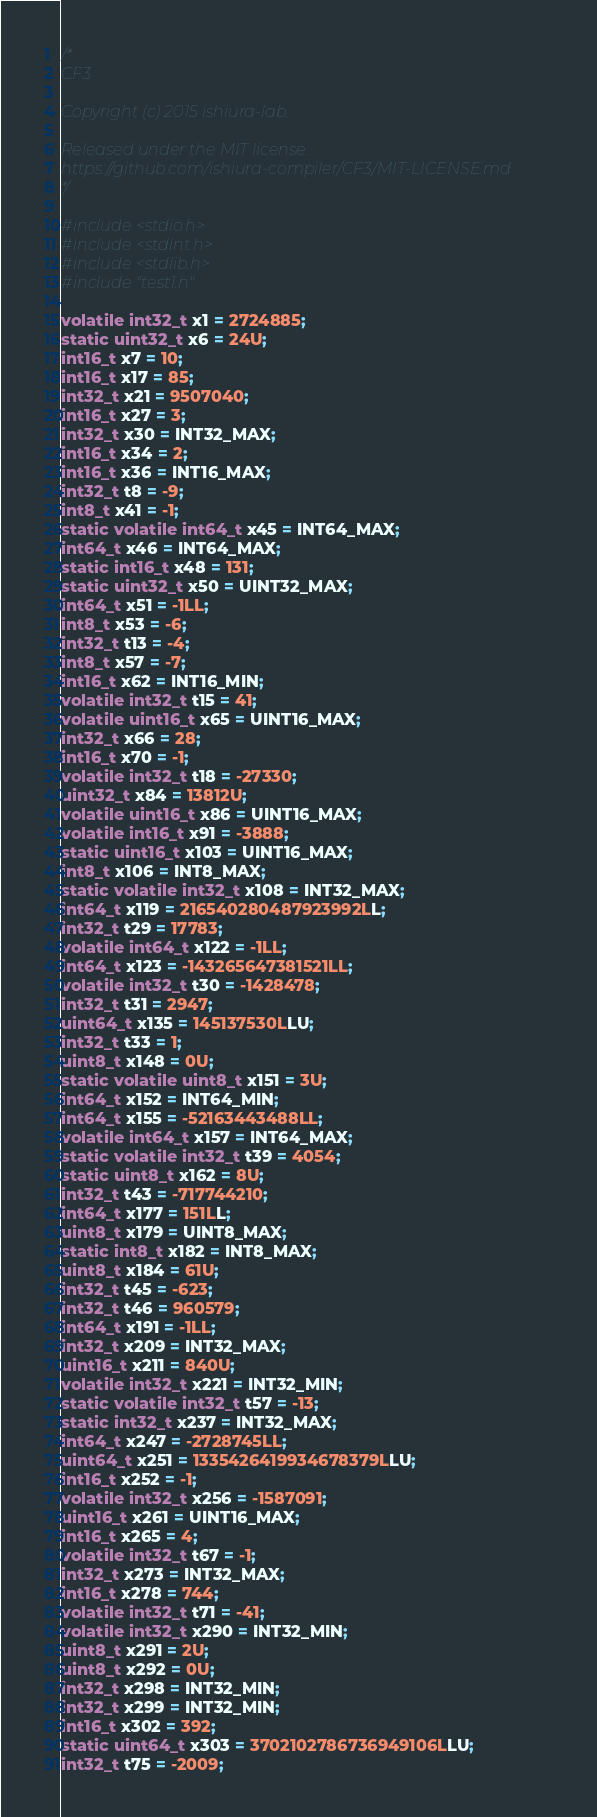<code> <loc_0><loc_0><loc_500><loc_500><_C_>
/*
CF3

Copyright (c) 2015 ishiura-lab.

Released under the MIT license.  
https://github.com/ishiura-compiler/CF3/MIT-LICENSE.md
*/

#include<stdio.h>
#include<stdint.h>
#include<stdlib.h>
#include"test1.h"

volatile int32_t x1 = 2724885;
static uint32_t x6 = 24U;
int16_t x7 = 10;
int16_t x17 = 85;
int32_t x21 = 9507040;
int16_t x27 = 3;
int32_t x30 = INT32_MAX;
int16_t x34 = 2;
int16_t x36 = INT16_MAX;
int32_t t8 = -9;
int8_t x41 = -1;
static volatile int64_t x45 = INT64_MAX;
int64_t x46 = INT64_MAX;
static int16_t x48 = 131;
static uint32_t x50 = UINT32_MAX;
int64_t x51 = -1LL;
int8_t x53 = -6;
int32_t t13 = -4;
int8_t x57 = -7;
int16_t x62 = INT16_MIN;
volatile int32_t t15 = 41;
volatile uint16_t x65 = UINT16_MAX;
int32_t x66 = 28;
int16_t x70 = -1;
volatile int32_t t18 = -27330;
uint32_t x84 = 13812U;
volatile uint16_t x86 = UINT16_MAX;
volatile int16_t x91 = -3888;
static uint16_t x103 = UINT16_MAX;
int8_t x106 = INT8_MAX;
static volatile int32_t x108 = INT32_MAX;
int64_t x119 = 216540280487923992LL;
int32_t t29 = 17783;
volatile int64_t x122 = -1LL;
int64_t x123 = -143265647381521LL;
volatile int32_t t30 = -1428478;
int32_t t31 = 2947;
uint64_t x135 = 145137530LLU;
int32_t t33 = 1;
uint8_t x148 = 0U;
static volatile uint8_t x151 = 3U;
int64_t x152 = INT64_MIN;
int64_t x155 = -52163443488LL;
volatile int64_t x157 = INT64_MAX;
static volatile int32_t t39 = 4054;
static uint8_t x162 = 8U;
int32_t t43 = -717744210;
int64_t x177 = 151LL;
uint8_t x179 = UINT8_MAX;
static int8_t x182 = INT8_MAX;
uint8_t x184 = 61U;
int32_t t45 = -623;
int32_t t46 = 960579;
int64_t x191 = -1LL;
int32_t x209 = INT32_MAX;
uint16_t x211 = 840U;
volatile int32_t x221 = INT32_MIN;
static volatile int32_t t57 = -13;
static int32_t x237 = INT32_MAX;
int64_t x247 = -2728745LL;
uint64_t x251 = 1335426419934678379LLU;
int16_t x252 = -1;
volatile int32_t x256 = -1587091;
uint16_t x261 = UINT16_MAX;
int16_t x265 = 4;
volatile int32_t t67 = -1;
int32_t x273 = INT32_MAX;
int16_t x278 = 744;
volatile int32_t t71 = -41;
volatile int32_t x290 = INT32_MIN;
uint8_t x291 = 2U;
uint8_t x292 = 0U;
int32_t x298 = INT32_MIN;
int32_t x299 = INT32_MIN;
int16_t x302 = 392;
static uint64_t x303 = 3702102786736949106LLU;
int32_t t75 = -2009;</code> 